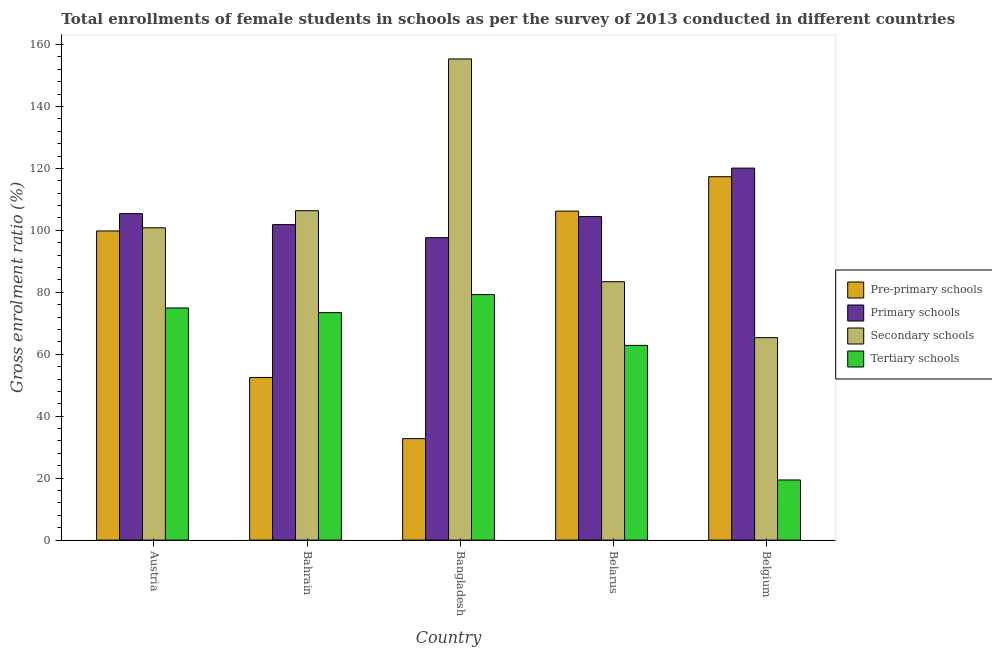Are the number of bars per tick equal to the number of legend labels?
Make the answer very short. Yes. How many bars are there on the 4th tick from the left?
Ensure brevity in your answer.  4. What is the label of the 2nd group of bars from the left?
Give a very brief answer. Bahrain. In how many cases, is the number of bars for a given country not equal to the number of legend labels?
Your response must be concise. 0. What is the gross enrolment ratio(female) in primary schools in Bangladesh?
Keep it short and to the point. 97.63. Across all countries, what is the maximum gross enrolment ratio(female) in secondary schools?
Offer a very short reply. 155.34. Across all countries, what is the minimum gross enrolment ratio(female) in pre-primary schools?
Your response must be concise. 32.76. In which country was the gross enrolment ratio(female) in tertiary schools maximum?
Your answer should be very brief. Bangladesh. In which country was the gross enrolment ratio(female) in secondary schools minimum?
Offer a terse response. Belgium. What is the total gross enrolment ratio(female) in primary schools in the graph?
Make the answer very short. 529.42. What is the difference between the gross enrolment ratio(female) in primary schools in Austria and that in Bangladesh?
Your response must be concise. 7.76. What is the difference between the gross enrolment ratio(female) in primary schools in Belarus and the gross enrolment ratio(female) in secondary schools in Austria?
Provide a short and direct response. 3.62. What is the average gross enrolment ratio(female) in secondary schools per country?
Provide a short and direct response. 102.26. What is the difference between the gross enrolment ratio(female) in secondary schools and gross enrolment ratio(female) in pre-primary schools in Belgium?
Make the answer very short. -51.95. What is the ratio of the gross enrolment ratio(female) in tertiary schools in Bangladesh to that in Belarus?
Make the answer very short. 1.26. What is the difference between the highest and the second highest gross enrolment ratio(female) in secondary schools?
Make the answer very short. 48.99. What is the difference between the highest and the lowest gross enrolment ratio(female) in tertiary schools?
Provide a short and direct response. 59.84. What does the 4th bar from the left in Bangladesh represents?
Your response must be concise. Tertiary schools. What does the 3rd bar from the right in Belarus represents?
Keep it short and to the point. Primary schools. How many bars are there?
Your response must be concise. 20. Are all the bars in the graph horizontal?
Keep it short and to the point. No. What is the difference between two consecutive major ticks on the Y-axis?
Give a very brief answer. 20. Where does the legend appear in the graph?
Provide a short and direct response. Center right. How are the legend labels stacked?
Your answer should be very brief. Vertical. What is the title of the graph?
Give a very brief answer. Total enrollments of female students in schools as per the survey of 2013 conducted in different countries. What is the label or title of the X-axis?
Ensure brevity in your answer.  Country. What is the Gross enrolment ratio (%) in Pre-primary schools in Austria?
Give a very brief answer. 99.8. What is the Gross enrolment ratio (%) in Primary schools in Austria?
Provide a short and direct response. 105.39. What is the Gross enrolment ratio (%) in Secondary schools in Austria?
Your answer should be compact. 100.83. What is the Gross enrolment ratio (%) in Tertiary schools in Austria?
Provide a short and direct response. 74.94. What is the Gross enrolment ratio (%) in Pre-primary schools in Bahrain?
Offer a very short reply. 52.51. What is the Gross enrolment ratio (%) of Primary schools in Bahrain?
Provide a succinct answer. 101.86. What is the Gross enrolment ratio (%) in Secondary schools in Bahrain?
Ensure brevity in your answer.  106.34. What is the Gross enrolment ratio (%) of Tertiary schools in Bahrain?
Your response must be concise. 73.43. What is the Gross enrolment ratio (%) in Pre-primary schools in Bangladesh?
Provide a succinct answer. 32.76. What is the Gross enrolment ratio (%) of Primary schools in Bangladesh?
Keep it short and to the point. 97.63. What is the Gross enrolment ratio (%) of Secondary schools in Bangladesh?
Offer a very short reply. 155.34. What is the Gross enrolment ratio (%) in Tertiary schools in Bangladesh?
Offer a very short reply. 79.26. What is the Gross enrolment ratio (%) in Pre-primary schools in Belarus?
Give a very brief answer. 106.21. What is the Gross enrolment ratio (%) of Primary schools in Belarus?
Give a very brief answer. 104.44. What is the Gross enrolment ratio (%) in Secondary schools in Belarus?
Offer a very short reply. 83.43. What is the Gross enrolment ratio (%) of Tertiary schools in Belarus?
Make the answer very short. 62.86. What is the Gross enrolment ratio (%) of Pre-primary schools in Belgium?
Offer a very short reply. 117.31. What is the Gross enrolment ratio (%) of Primary schools in Belgium?
Your answer should be very brief. 120.09. What is the Gross enrolment ratio (%) in Secondary schools in Belgium?
Keep it short and to the point. 65.36. What is the Gross enrolment ratio (%) in Tertiary schools in Belgium?
Provide a short and direct response. 19.41. Across all countries, what is the maximum Gross enrolment ratio (%) of Pre-primary schools?
Make the answer very short. 117.31. Across all countries, what is the maximum Gross enrolment ratio (%) in Primary schools?
Provide a succinct answer. 120.09. Across all countries, what is the maximum Gross enrolment ratio (%) in Secondary schools?
Offer a very short reply. 155.34. Across all countries, what is the maximum Gross enrolment ratio (%) of Tertiary schools?
Make the answer very short. 79.26. Across all countries, what is the minimum Gross enrolment ratio (%) in Pre-primary schools?
Offer a terse response. 32.76. Across all countries, what is the minimum Gross enrolment ratio (%) in Primary schools?
Your answer should be very brief. 97.63. Across all countries, what is the minimum Gross enrolment ratio (%) in Secondary schools?
Offer a terse response. 65.36. Across all countries, what is the minimum Gross enrolment ratio (%) of Tertiary schools?
Provide a short and direct response. 19.41. What is the total Gross enrolment ratio (%) of Pre-primary schools in the graph?
Your answer should be compact. 408.6. What is the total Gross enrolment ratio (%) of Primary schools in the graph?
Provide a short and direct response. 529.42. What is the total Gross enrolment ratio (%) in Secondary schools in the graph?
Offer a very short reply. 511.3. What is the total Gross enrolment ratio (%) in Tertiary schools in the graph?
Offer a very short reply. 309.91. What is the difference between the Gross enrolment ratio (%) in Pre-primary schools in Austria and that in Bahrain?
Provide a short and direct response. 47.29. What is the difference between the Gross enrolment ratio (%) in Primary schools in Austria and that in Bahrain?
Ensure brevity in your answer.  3.54. What is the difference between the Gross enrolment ratio (%) in Secondary schools in Austria and that in Bahrain?
Give a very brief answer. -5.52. What is the difference between the Gross enrolment ratio (%) of Tertiary schools in Austria and that in Bahrain?
Offer a terse response. 1.51. What is the difference between the Gross enrolment ratio (%) in Pre-primary schools in Austria and that in Bangladesh?
Provide a succinct answer. 67.04. What is the difference between the Gross enrolment ratio (%) of Primary schools in Austria and that in Bangladesh?
Provide a succinct answer. 7.76. What is the difference between the Gross enrolment ratio (%) in Secondary schools in Austria and that in Bangladesh?
Offer a terse response. -54.51. What is the difference between the Gross enrolment ratio (%) of Tertiary schools in Austria and that in Bangladesh?
Your answer should be very brief. -4.31. What is the difference between the Gross enrolment ratio (%) of Pre-primary schools in Austria and that in Belarus?
Your answer should be compact. -6.41. What is the difference between the Gross enrolment ratio (%) in Primary schools in Austria and that in Belarus?
Provide a short and direct response. 0.95. What is the difference between the Gross enrolment ratio (%) in Secondary schools in Austria and that in Belarus?
Your answer should be compact. 17.4. What is the difference between the Gross enrolment ratio (%) in Tertiary schools in Austria and that in Belarus?
Your response must be concise. 12.08. What is the difference between the Gross enrolment ratio (%) in Pre-primary schools in Austria and that in Belgium?
Offer a terse response. -17.51. What is the difference between the Gross enrolment ratio (%) in Primary schools in Austria and that in Belgium?
Ensure brevity in your answer.  -14.7. What is the difference between the Gross enrolment ratio (%) of Secondary schools in Austria and that in Belgium?
Provide a short and direct response. 35.46. What is the difference between the Gross enrolment ratio (%) of Tertiary schools in Austria and that in Belgium?
Provide a short and direct response. 55.53. What is the difference between the Gross enrolment ratio (%) of Pre-primary schools in Bahrain and that in Bangladesh?
Provide a succinct answer. 19.75. What is the difference between the Gross enrolment ratio (%) of Primary schools in Bahrain and that in Bangladesh?
Your answer should be very brief. 4.22. What is the difference between the Gross enrolment ratio (%) of Secondary schools in Bahrain and that in Bangladesh?
Provide a succinct answer. -48.99. What is the difference between the Gross enrolment ratio (%) in Tertiary schools in Bahrain and that in Bangladesh?
Provide a succinct answer. -5.82. What is the difference between the Gross enrolment ratio (%) in Pre-primary schools in Bahrain and that in Belarus?
Offer a terse response. -53.7. What is the difference between the Gross enrolment ratio (%) of Primary schools in Bahrain and that in Belarus?
Provide a short and direct response. -2.59. What is the difference between the Gross enrolment ratio (%) of Secondary schools in Bahrain and that in Belarus?
Offer a terse response. 22.92. What is the difference between the Gross enrolment ratio (%) in Tertiary schools in Bahrain and that in Belarus?
Offer a very short reply. 10.57. What is the difference between the Gross enrolment ratio (%) in Pre-primary schools in Bahrain and that in Belgium?
Offer a very short reply. -64.8. What is the difference between the Gross enrolment ratio (%) in Primary schools in Bahrain and that in Belgium?
Your answer should be compact. -18.24. What is the difference between the Gross enrolment ratio (%) of Secondary schools in Bahrain and that in Belgium?
Provide a short and direct response. 40.98. What is the difference between the Gross enrolment ratio (%) of Tertiary schools in Bahrain and that in Belgium?
Offer a very short reply. 54.02. What is the difference between the Gross enrolment ratio (%) of Pre-primary schools in Bangladesh and that in Belarus?
Your answer should be compact. -73.45. What is the difference between the Gross enrolment ratio (%) of Primary schools in Bangladesh and that in Belarus?
Keep it short and to the point. -6.81. What is the difference between the Gross enrolment ratio (%) in Secondary schools in Bangladesh and that in Belarus?
Offer a terse response. 71.91. What is the difference between the Gross enrolment ratio (%) of Tertiary schools in Bangladesh and that in Belarus?
Provide a succinct answer. 16.4. What is the difference between the Gross enrolment ratio (%) of Pre-primary schools in Bangladesh and that in Belgium?
Give a very brief answer. -84.55. What is the difference between the Gross enrolment ratio (%) of Primary schools in Bangladesh and that in Belgium?
Ensure brevity in your answer.  -22.46. What is the difference between the Gross enrolment ratio (%) of Secondary schools in Bangladesh and that in Belgium?
Ensure brevity in your answer.  89.97. What is the difference between the Gross enrolment ratio (%) of Tertiary schools in Bangladesh and that in Belgium?
Provide a short and direct response. 59.84. What is the difference between the Gross enrolment ratio (%) in Pre-primary schools in Belarus and that in Belgium?
Offer a very short reply. -11.1. What is the difference between the Gross enrolment ratio (%) in Primary schools in Belarus and that in Belgium?
Give a very brief answer. -15.65. What is the difference between the Gross enrolment ratio (%) of Secondary schools in Belarus and that in Belgium?
Give a very brief answer. 18.06. What is the difference between the Gross enrolment ratio (%) of Tertiary schools in Belarus and that in Belgium?
Your answer should be very brief. 43.45. What is the difference between the Gross enrolment ratio (%) in Pre-primary schools in Austria and the Gross enrolment ratio (%) in Primary schools in Bahrain?
Provide a succinct answer. -2.05. What is the difference between the Gross enrolment ratio (%) of Pre-primary schools in Austria and the Gross enrolment ratio (%) of Secondary schools in Bahrain?
Provide a succinct answer. -6.54. What is the difference between the Gross enrolment ratio (%) of Pre-primary schools in Austria and the Gross enrolment ratio (%) of Tertiary schools in Bahrain?
Your response must be concise. 26.37. What is the difference between the Gross enrolment ratio (%) of Primary schools in Austria and the Gross enrolment ratio (%) of Secondary schools in Bahrain?
Your answer should be compact. -0.95. What is the difference between the Gross enrolment ratio (%) of Primary schools in Austria and the Gross enrolment ratio (%) of Tertiary schools in Bahrain?
Offer a terse response. 31.96. What is the difference between the Gross enrolment ratio (%) of Secondary schools in Austria and the Gross enrolment ratio (%) of Tertiary schools in Bahrain?
Your answer should be very brief. 27.39. What is the difference between the Gross enrolment ratio (%) of Pre-primary schools in Austria and the Gross enrolment ratio (%) of Primary schools in Bangladesh?
Give a very brief answer. 2.17. What is the difference between the Gross enrolment ratio (%) in Pre-primary schools in Austria and the Gross enrolment ratio (%) in Secondary schools in Bangladesh?
Make the answer very short. -55.53. What is the difference between the Gross enrolment ratio (%) of Pre-primary schools in Austria and the Gross enrolment ratio (%) of Tertiary schools in Bangladesh?
Provide a short and direct response. 20.55. What is the difference between the Gross enrolment ratio (%) of Primary schools in Austria and the Gross enrolment ratio (%) of Secondary schools in Bangladesh?
Offer a terse response. -49.94. What is the difference between the Gross enrolment ratio (%) of Primary schools in Austria and the Gross enrolment ratio (%) of Tertiary schools in Bangladesh?
Offer a very short reply. 26.14. What is the difference between the Gross enrolment ratio (%) of Secondary schools in Austria and the Gross enrolment ratio (%) of Tertiary schools in Bangladesh?
Ensure brevity in your answer.  21.57. What is the difference between the Gross enrolment ratio (%) of Pre-primary schools in Austria and the Gross enrolment ratio (%) of Primary schools in Belarus?
Make the answer very short. -4.64. What is the difference between the Gross enrolment ratio (%) of Pre-primary schools in Austria and the Gross enrolment ratio (%) of Secondary schools in Belarus?
Your response must be concise. 16.38. What is the difference between the Gross enrolment ratio (%) in Pre-primary schools in Austria and the Gross enrolment ratio (%) in Tertiary schools in Belarus?
Your response must be concise. 36.94. What is the difference between the Gross enrolment ratio (%) in Primary schools in Austria and the Gross enrolment ratio (%) in Secondary schools in Belarus?
Provide a succinct answer. 21.97. What is the difference between the Gross enrolment ratio (%) in Primary schools in Austria and the Gross enrolment ratio (%) in Tertiary schools in Belarus?
Give a very brief answer. 42.53. What is the difference between the Gross enrolment ratio (%) of Secondary schools in Austria and the Gross enrolment ratio (%) of Tertiary schools in Belarus?
Provide a short and direct response. 37.97. What is the difference between the Gross enrolment ratio (%) of Pre-primary schools in Austria and the Gross enrolment ratio (%) of Primary schools in Belgium?
Keep it short and to the point. -20.29. What is the difference between the Gross enrolment ratio (%) of Pre-primary schools in Austria and the Gross enrolment ratio (%) of Secondary schools in Belgium?
Offer a terse response. 34.44. What is the difference between the Gross enrolment ratio (%) in Pre-primary schools in Austria and the Gross enrolment ratio (%) in Tertiary schools in Belgium?
Your answer should be very brief. 80.39. What is the difference between the Gross enrolment ratio (%) of Primary schools in Austria and the Gross enrolment ratio (%) of Secondary schools in Belgium?
Offer a terse response. 40.03. What is the difference between the Gross enrolment ratio (%) of Primary schools in Austria and the Gross enrolment ratio (%) of Tertiary schools in Belgium?
Make the answer very short. 85.98. What is the difference between the Gross enrolment ratio (%) of Secondary schools in Austria and the Gross enrolment ratio (%) of Tertiary schools in Belgium?
Offer a terse response. 81.41. What is the difference between the Gross enrolment ratio (%) of Pre-primary schools in Bahrain and the Gross enrolment ratio (%) of Primary schools in Bangladesh?
Make the answer very short. -45.12. What is the difference between the Gross enrolment ratio (%) of Pre-primary schools in Bahrain and the Gross enrolment ratio (%) of Secondary schools in Bangladesh?
Offer a very short reply. -102.82. What is the difference between the Gross enrolment ratio (%) in Pre-primary schools in Bahrain and the Gross enrolment ratio (%) in Tertiary schools in Bangladesh?
Provide a short and direct response. -26.74. What is the difference between the Gross enrolment ratio (%) in Primary schools in Bahrain and the Gross enrolment ratio (%) in Secondary schools in Bangladesh?
Provide a succinct answer. -53.48. What is the difference between the Gross enrolment ratio (%) in Primary schools in Bahrain and the Gross enrolment ratio (%) in Tertiary schools in Bangladesh?
Your answer should be compact. 22.6. What is the difference between the Gross enrolment ratio (%) in Secondary schools in Bahrain and the Gross enrolment ratio (%) in Tertiary schools in Bangladesh?
Your response must be concise. 27.09. What is the difference between the Gross enrolment ratio (%) of Pre-primary schools in Bahrain and the Gross enrolment ratio (%) of Primary schools in Belarus?
Offer a terse response. -51.93. What is the difference between the Gross enrolment ratio (%) in Pre-primary schools in Bahrain and the Gross enrolment ratio (%) in Secondary schools in Belarus?
Your response must be concise. -30.91. What is the difference between the Gross enrolment ratio (%) in Pre-primary schools in Bahrain and the Gross enrolment ratio (%) in Tertiary schools in Belarus?
Keep it short and to the point. -10.35. What is the difference between the Gross enrolment ratio (%) of Primary schools in Bahrain and the Gross enrolment ratio (%) of Secondary schools in Belarus?
Your answer should be compact. 18.43. What is the difference between the Gross enrolment ratio (%) in Primary schools in Bahrain and the Gross enrolment ratio (%) in Tertiary schools in Belarus?
Your answer should be very brief. 39. What is the difference between the Gross enrolment ratio (%) in Secondary schools in Bahrain and the Gross enrolment ratio (%) in Tertiary schools in Belarus?
Your answer should be compact. 43.48. What is the difference between the Gross enrolment ratio (%) in Pre-primary schools in Bahrain and the Gross enrolment ratio (%) in Primary schools in Belgium?
Make the answer very short. -67.58. What is the difference between the Gross enrolment ratio (%) in Pre-primary schools in Bahrain and the Gross enrolment ratio (%) in Secondary schools in Belgium?
Ensure brevity in your answer.  -12.85. What is the difference between the Gross enrolment ratio (%) of Pre-primary schools in Bahrain and the Gross enrolment ratio (%) of Tertiary schools in Belgium?
Provide a succinct answer. 33.1. What is the difference between the Gross enrolment ratio (%) in Primary schools in Bahrain and the Gross enrolment ratio (%) in Secondary schools in Belgium?
Keep it short and to the point. 36.49. What is the difference between the Gross enrolment ratio (%) of Primary schools in Bahrain and the Gross enrolment ratio (%) of Tertiary schools in Belgium?
Offer a terse response. 82.44. What is the difference between the Gross enrolment ratio (%) in Secondary schools in Bahrain and the Gross enrolment ratio (%) in Tertiary schools in Belgium?
Ensure brevity in your answer.  86.93. What is the difference between the Gross enrolment ratio (%) in Pre-primary schools in Bangladesh and the Gross enrolment ratio (%) in Primary schools in Belarus?
Ensure brevity in your answer.  -71.68. What is the difference between the Gross enrolment ratio (%) in Pre-primary schools in Bangladesh and the Gross enrolment ratio (%) in Secondary schools in Belarus?
Provide a succinct answer. -50.66. What is the difference between the Gross enrolment ratio (%) of Pre-primary schools in Bangladesh and the Gross enrolment ratio (%) of Tertiary schools in Belarus?
Your answer should be compact. -30.1. What is the difference between the Gross enrolment ratio (%) of Primary schools in Bangladesh and the Gross enrolment ratio (%) of Secondary schools in Belarus?
Ensure brevity in your answer.  14.21. What is the difference between the Gross enrolment ratio (%) in Primary schools in Bangladesh and the Gross enrolment ratio (%) in Tertiary schools in Belarus?
Provide a short and direct response. 34.77. What is the difference between the Gross enrolment ratio (%) in Secondary schools in Bangladesh and the Gross enrolment ratio (%) in Tertiary schools in Belarus?
Keep it short and to the point. 92.48. What is the difference between the Gross enrolment ratio (%) of Pre-primary schools in Bangladesh and the Gross enrolment ratio (%) of Primary schools in Belgium?
Keep it short and to the point. -87.33. What is the difference between the Gross enrolment ratio (%) of Pre-primary schools in Bangladesh and the Gross enrolment ratio (%) of Secondary schools in Belgium?
Your answer should be very brief. -32.6. What is the difference between the Gross enrolment ratio (%) of Pre-primary schools in Bangladesh and the Gross enrolment ratio (%) of Tertiary schools in Belgium?
Offer a terse response. 13.35. What is the difference between the Gross enrolment ratio (%) in Primary schools in Bangladesh and the Gross enrolment ratio (%) in Secondary schools in Belgium?
Your answer should be compact. 32.27. What is the difference between the Gross enrolment ratio (%) in Primary schools in Bangladesh and the Gross enrolment ratio (%) in Tertiary schools in Belgium?
Keep it short and to the point. 78.22. What is the difference between the Gross enrolment ratio (%) in Secondary schools in Bangladesh and the Gross enrolment ratio (%) in Tertiary schools in Belgium?
Your response must be concise. 135.92. What is the difference between the Gross enrolment ratio (%) in Pre-primary schools in Belarus and the Gross enrolment ratio (%) in Primary schools in Belgium?
Ensure brevity in your answer.  -13.88. What is the difference between the Gross enrolment ratio (%) in Pre-primary schools in Belarus and the Gross enrolment ratio (%) in Secondary schools in Belgium?
Provide a succinct answer. 40.85. What is the difference between the Gross enrolment ratio (%) of Pre-primary schools in Belarus and the Gross enrolment ratio (%) of Tertiary schools in Belgium?
Your response must be concise. 86.8. What is the difference between the Gross enrolment ratio (%) of Primary schools in Belarus and the Gross enrolment ratio (%) of Secondary schools in Belgium?
Ensure brevity in your answer.  39.08. What is the difference between the Gross enrolment ratio (%) in Primary schools in Belarus and the Gross enrolment ratio (%) in Tertiary schools in Belgium?
Keep it short and to the point. 85.03. What is the difference between the Gross enrolment ratio (%) of Secondary schools in Belarus and the Gross enrolment ratio (%) of Tertiary schools in Belgium?
Your answer should be compact. 64.01. What is the average Gross enrolment ratio (%) of Pre-primary schools per country?
Provide a succinct answer. 81.72. What is the average Gross enrolment ratio (%) of Primary schools per country?
Your answer should be compact. 105.88. What is the average Gross enrolment ratio (%) in Secondary schools per country?
Offer a terse response. 102.26. What is the average Gross enrolment ratio (%) in Tertiary schools per country?
Provide a short and direct response. 61.98. What is the difference between the Gross enrolment ratio (%) of Pre-primary schools and Gross enrolment ratio (%) of Primary schools in Austria?
Offer a terse response. -5.59. What is the difference between the Gross enrolment ratio (%) in Pre-primary schools and Gross enrolment ratio (%) in Secondary schools in Austria?
Give a very brief answer. -1.02. What is the difference between the Gross enrolment ratio (%) in Pre-primary schools and Gross enrolment ratio (%) in Tertiary schools in Austria?
Offer a terse response. 24.86. What is the difference between the Gross enrolment ratio (%) in Primary schools and Gross enrolment ratio (%) in Secondary schools in Austria?
Provide a short and direct response. 4.57. What is the difference between the Gross enrolment ratio (%) in Primary schools and Gross enrolment ratio (%) in Tertiary schools in Austria?
Your response must be concise. 30.45. What is the difference between the Gross enrolment ratio (%) in Secondary schools and Gross enrolment ratio (%) in Tertiary schools in Austria?
Provide a succinct answer. 25.88. What is the difference between the Gross enrolment ratio (%) in Pre-primary schools and Gross enrolment ratio (%) in Primary schools in Bahrain?
Your response must be concise. -49.34. What is the difference between the Gross enrolment ratio (%) in Pre-primary schools and Gross enrolment ratio (%) in Secondary schools in Bahrain?
Your response must be concise. -53.83. What is the difference between the Gross enrolment ratio (%) in Pre-primary schools and Gross enrolment ratio (%) in Tertiary schools in Bahrain?
Your answer should be compact. -20.92. What is the difference between the Gross enrolment ratio (%) of Primary schools and Gross enrolment ratio (%) of Secondary schools in Bahrain?
Make the answer very short. -4.49. What is the difference between the Gross enrolment ratio (%) in Primary schools and Gross enrolment ratio (%) in Tertiary schools in Bahrain?
Offer a very short reply. 28.42. What is the difference between the Gross enrolment ratio (%) of Secondary schools and Gross enrolment ratio (%) of Tertiary schools in Bahrain?
Keep it short and to the point. 32.91. What is the difference between the Gross enrolment ratio (%) of Pre-primary schools and Gross enrolment ratio (%) of Primary schools in Bangladesh?
Offer a terse response. -64.87. What is the difference between the Gross enrolment ratio (%) in Pre-primary schools and Gross enrolment ratio (%) in Secondary schools in Bangladesh?
Offer a terse response. -122.58. What is the difference between the Gross enrolment ratio (%) in Pre-primary schools and Gross enrolment ratio (%) in Tertiary schools in Bangladesh?
Provide a short and direct response. -46.49. What is the difference between the Gross enrolment ratio (%) in Primary schools and Gross enrolment ratio (%) in Secondary schools in Bangladesh?
Your answer should be very brief. -57.7. What is the difference between the Gross enrolment ratio (%) in Primary schools and Gross enrolment ratio (%) in Tertiary schools in Bangladesh?
Your answer should be very brief. 18.38. What is the difference between the Gross enrolment ratio (%) of Secondary schools and Gross enrolment ratio (%) of Tertiary schools in Bangladesh?
Your answer should be compact. 76.08. What is the difference between the Gross enrolment ratio (%) in Pre-primary schools and Gross enrolment ratio (%) in Primary schools in Belarus?
Offer a very short reply. 1.77. What is the difference between the Gross enrolment ratio (%) in Pre-primary schools and Gross enrolment ratio (%) in Secondary schools in Belarus?
Your answer should be compact. 22.78. What is the difference between the Gross enrolment ratio (%) in Pre-primary schools and Gross enrolment ratio (%) in Tertiary schools in Belarus?
Offer a terse response. 43.35. What is the difference between the Gross enrolment ratio (%) of Primary schools and Gross enrolment ratio (%) of Secondary schools in Belarus?
Keep it short and to the point. 21.02. What is the difference between the Gross enrolment ratio (%) in Primary schools and Gross enrolment ratio (%) in Tertiary schools in Belarus?
Offer a very short reply. 41.58. What is the difference between the Gross enrolment ratio (%) of Secondary schools and Gross enrolment ratio (%) of Tertiary schools in Belarus?
Your response must be concise. 20.57. What is the difference between the Gross enrolment ratio (%) of Pre-primary schools and Gross enrolment ratio (%) of Primary schools in Belgium?
Make the answer very short. -2.78. What is the difference between the Gross enrolment ratio (%) of Pre-primary schools and Gross enrolment ratio (%) of Secondary schools in Belgium?
Provide a short and direct response. 51.95. What is the difference between the Gross enrolment ratio (%) in Pre-primary schools and Gross enrolment ratio (%) in Tertiary schools in Belgium?
Your answer should be compact. 97.9. What is the difference between the Gross enrolment ratio (%) in Primary schools and Gross enrolment ratio (%) in Secondary schools in Belgium?
Offer a terse response. 54.73. What is the difference between the Gross enrolment ratio (%) of Primary schools and Gross enrolment ratio (%) of Tertiary schools in Belgium?
Make the answer very short. 100.68. What is the difference between the Gross enrolment ratio (%) of Secondary schools and Gross enrolment ratio (%) of Tertiary schools in Belgium?
Ensure brevity in your answer.  45.95. What is the ratio of the Gross enrolment ratio (%) in Pre-primary schools in Austria to that in Bahrain?
Your answer should be very brief. 1.9. What is the ratio of the Gross enrolment ratio (%) in Primary schools in Austria to that in Bahrain?
Provide a succinct answer. 1.03. What is the ratio of the Gross enrolment ratio (%) in Secondary schools in Austria to that in Bahrain?
Ensure brevity in your answer.  0.95. What is the ratio of the Gross enrolment ratio (%) in Tertiary schools in Austria to that in Bahrain?
Your answer should be compact. 1.02. What is the ratio of the Gross enrolment ratio (%) in Pre-primary schools in Austria to that in Bangladesh?
Provide a short and direct response. 3.05. What is the ratio of the Gross enrolment ratio (%) of Primary schools in Austria to that in Bangladesh?
Make the answer very short. 1.08. What is the ratio of the Gross enrolment ratio (%) in Secondary schools in Austria to that in Bangladesh?
Offer a terse response. 0.65. What is the ratio of the Gross enrolment ratio (%) in Tertiary schools in Austria to that in Bangladesh?
Provide a succinct answer. 0.95. What is the ratio of the Gross enrolment ratio (%) of Pre-primary schools in Austria to that in Belarus?
Ensure brevity in your answer.  0.94. What is the ratio of the Gross enrolment ratio (%) in Primary schools in Austria to that in Belarus?
Keep it short and to the point. 1.01. What is the ratio of the Gross enrolment ratio (%) of Secondary schools in Austria to that in Belarus?
Make the answer very short. 1.21. What is the ratio of the Gross enrolment ratio (%) in Tertiary schools in Austria to that in Belarus?
Provide a short and direct response. 1.19. What is the ratio of the Gross enrolment ratio (%) of Pre-primary schools in Austria to that in Belgium?
Ensure brevity in your answer.  0.85. What is the ratio of the Gross enrolment ratio (%) of Primary schools in Austria to that in Belgium?
Your response must be concise. 0.88. What is the ratio of the Gross enrolment ratio (%) of Secondary schools in Austria to that in Belgium?
Provide a short and direct response. 1.54. What is the ratio of the Gross enrolment ratio (%) in Tertiary schools in Austria to that in Belgium?
Make the answer very short. 3.86. What is the ratio of the Gross enrolment ratio (%) of Pre-primary schools in Bahrain to that in Bangladesh?
Give a very brief answer. 1.6. What is the ratio of the Gross enrolment ratio (%) in Primary schools in Bahrain to that in Bangladesh?
Your answer should be very brief. 1.04. What is the ratio of the Gross enrolment ratio (%) in Secondary schools in Bahrain to that in Bangladesh?
Make the answer very short. 0.68. What is the ratio of the Gross enrolment ratio (%) in Tertiary schools in Bahrain to that in Bangladesh?
Offer a very short reply. 0.93. What is the ratio of the Gross enrolment ratio (%) of Pre-primary schools in Bahrain to that in Belarus?
Your answer should be compact. 0.49. What is the ratio of the Gross enrolment ratio (%) of Primary schools in Bahrain to that in Belarus?
Your answer should be very brief. 0.98. What is the ratio of the Gross enrolment ratio (%) in Secondary schools in Bahrain to that in Belarus?
Your answer should be very brief. 1.27. What is the ratio of the Gross enrolment ratio (%) of Tertiary schools in Bahrain to that in Belarus?
Offer a terse response. 1.17. What is the ratio of the Gross enrolment ratio (%) in Pre-primary schools in Bahrain to that in Belgium?
Provide a succinct answer. 0.45. What is the ratio of the Gross enrolment ratio (%) in Primary schools in Bahrain to that in Belgium?
Your answer should be compact. 0.85. What is the ratio of the Gross enrolment ratio (%) in Secondary schools in Bahrain to that in Belgium?
Provide a succinct answer. 1.63. What is the ratio of the Gross enrolment ratio (%) in Tertiary schools in Bahrain to that in Belgium?
Make the answer very short. 3.78. What is the ratio of the Gross enrolment ratio (%) of Pre-primary schools in Bangladesh to that in Belarus?
Provide a short and direct response. 0.31. What is the ratio of the Gross enrolment ratio (%) of Primary schools in Bangladesh to that in Belarus?
Your answer should be compact. 0.93. What is the ratio of the Gross enrolment ratio (%) of Secondary schools in Bangladesh to that in Belarus?
Give a very brief answer. 1.86. What is the ratio of the Gross enrolment ratio (%) in Tertiary schools in Bangladesh to that in Belarus?
Provide a short and direct response. 1.26. What is the ratio of the Gross enrolment ratio (%) of Pre-primary schools in Bangladesh to that in Belgium?
Provide a short and direct response. 0.28. What is the ratio of the Gross enrolment ratio (%) in Primary schools in Bangladesh to that in Belgium?
Your answer should be very brief. 0.81. What is the ratio of the Gross enrolment ratio (%) of Secondary schools in Bangladesh to that in Belgium?
Your response must be concise. 2.38. What is the ratio of the Gross enrolment ratio (%) in Tertiary schools in Bangladesh to that in Belgium?
Provide a succinct answer. 4.08. What is the ratio of the Gross enrolment ratio (%) in Pre-primary schools in Belarus to that in Belgium?
Your response must be concise. 0.91. What is the ratio of the Gross enrolment ratio (%) in Primary schools in Belarus to that in Belgium?
Your answer should be compact. 0.87. What is the ratio of the Gross enrolment ratio (%) of Secondary schools in Belarus to that in Belgium?
Make the answer very short. 1.28. What is the ratio of the Gross enrolment ratio (%) of Tertiary schools in Belarus to that in Belgium?
Offer a very short reply. 3.24. What is the difference between the highest and the second highest Gross enrolment ratio (%) in Pre-primary schools?
Give a very brief answer. 11.1. What is the difference between the highest and the second highest Gross enrolment ratio (%) of Primary schools?
Your answer should be very brief. 14.7. What is the difference between the highest and the second highest Gross enrolment ratio (%) of Secondary schools?
Make the answer very short. 48.99. What is the difference between the highest and the second highest Gross enrolment ratio (%) of Tertiary schools?
Keep it short and to the point. 4.31. What is the difference between the highest and the lowest Gross enrolment ratio (%) of Pre-primary schools?
Your response must be concise. 84.55. What is the difference between the highest and the lowest Gross enrolment ratio (%) in Primary schools?
Your answer should be compact. 22.46. What is the difference between the highest and the lowest Gross enrolment ratio (%) in Secondary schools?
Your response must be concise. 89.97. What is the difference between the highest and the lowest Gross enrolment ratio (%) in Tertiary schools?
Keep it short and to the point. 59.84. 